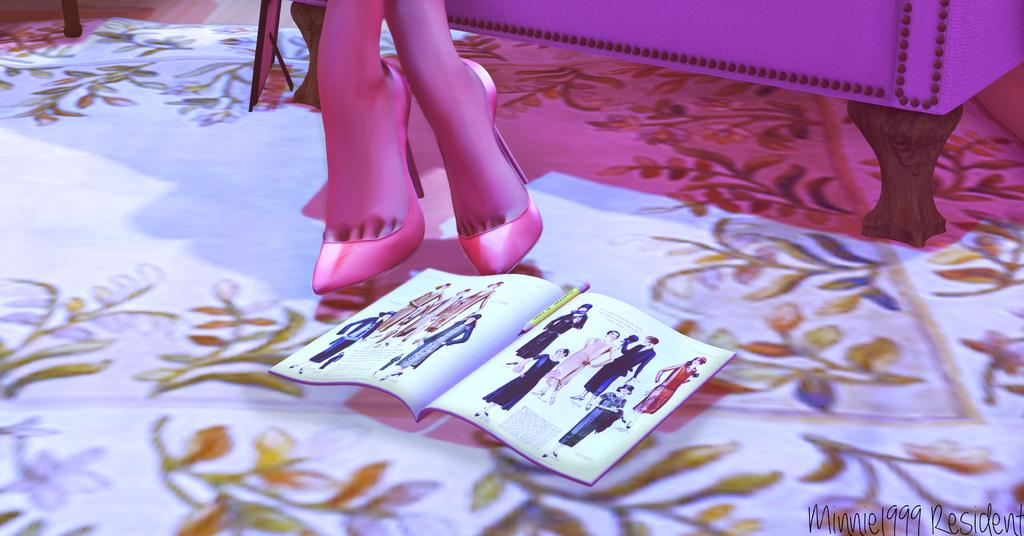What type of image is being described? The image is an animated image. What part of a woman's body can be seen in the image? There are a woman's legs visible in the image. What objects are present on the floor in the image? There is a magazine and a pencil placed on the floor in the image. What type of icicle can be seen hanging from the woman's legs in the image? There is no icicle present in the image; it is an animated image with a woman's legs visible. Can you describe the stranger in the image? There is no stranger present in the image; it only features a woman's legs, a magazine, and a pencil. 